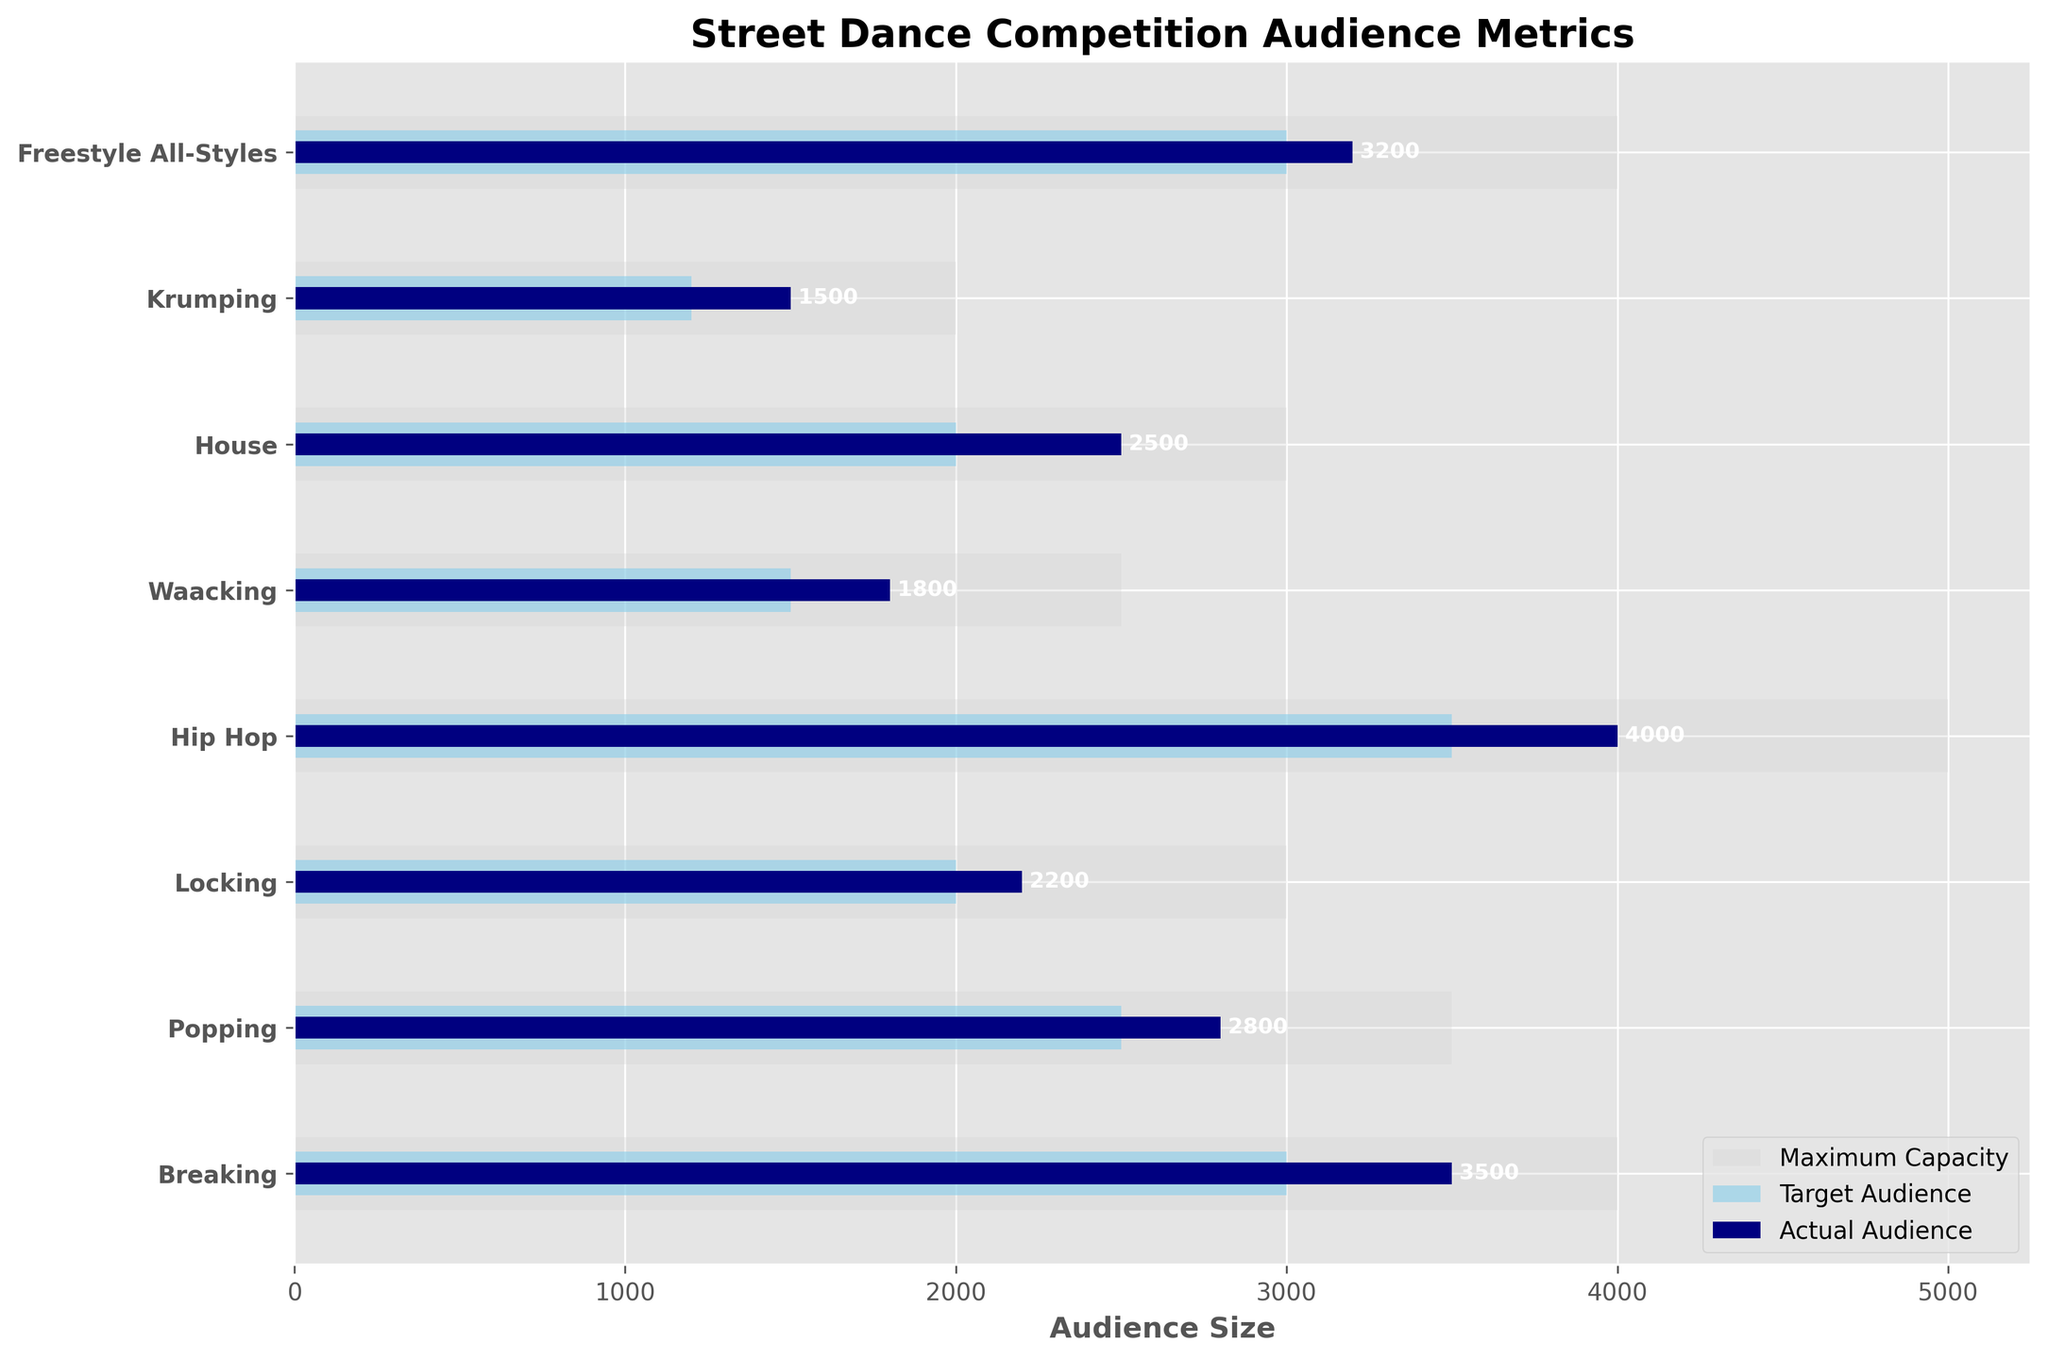What is the title of the chart? Look at the top of the plot to identify the main title.
Answer: Street Dance Competition Audience Metrics Which event type had the highest actual audience size? Compare the lengths of the darkest bars representing actual audience sizes. The longest bar corresponds to this event type.
Answer: Hip Hop How much larger was the actual audience in Tokyo compared to Miami? Find the actual audience sizes for both cities and calculate the difference: 4000 (Tokyo) - 1500 (Miami) = 2500.
Answer: 2500 Which event type in Paris had a higher actual audience than its target audience? Locate Paris on the y-axis, then compare the lengths of the light blue and dark blue bars. The dark blue bar representing the actual audience is longer.
Answer: Locking How many events had an actual audience that reached or exceeded their target audience? Count the number of events where the dark blue bar is as long as or longer than the light blue bar representing the target audience.
Answer: 5 Which city had the lowest maximum capacity? Compare the lengths of the light grey bars and find the shortest one.
Answer: Miami Is the actual audience size of the Breaking event in New York City closer to its target audience or maximum capacity? Compare the lengths of the actual audience (dark blue bar), target audience (light blue bar), and maximum capacity (light grey bar) for the Breaking event.
Answer: Target Audience Which event had an actual audience exactly equal to its target audience? Look for events where the dark blue bar is exactly the same length as the light blue bar.
Answer: Freestyle All-Styles What is the total actual audience size of events in New York City and Los Angeles combined? Sum the actual audience sizes for these two locations: 3500 (New York City) + 2800 (Los Angeles) = 6300.
Answer: 6300 How does the target audience for the Waacking event in London compare to the actual audience for the House event in Berlin? Compare the lengths of the light blue bar for London (Waacking) with the dark blue bar for Berlin (House).
Answer: Waacking's target audience is smaller 